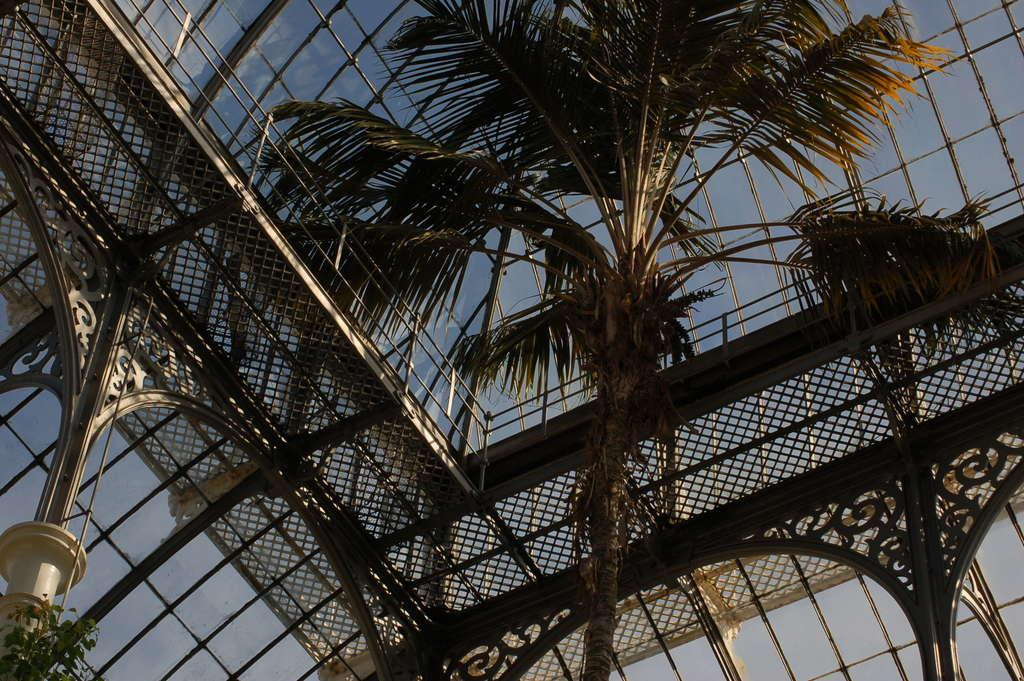What type of natural element is present in the image? There is a tree in the image. What type of architectural feature can be seen in the image? There is railing in the image. What other objects are present in the image besides the tree and railing? There are other objects in the image. What can be seen in the background of the image? The sky is visible in the background of the image. Where can the popcorn be found in the image? There is no popcorn present in the image. What type of market is visible in the image? There is no market present in the image. 